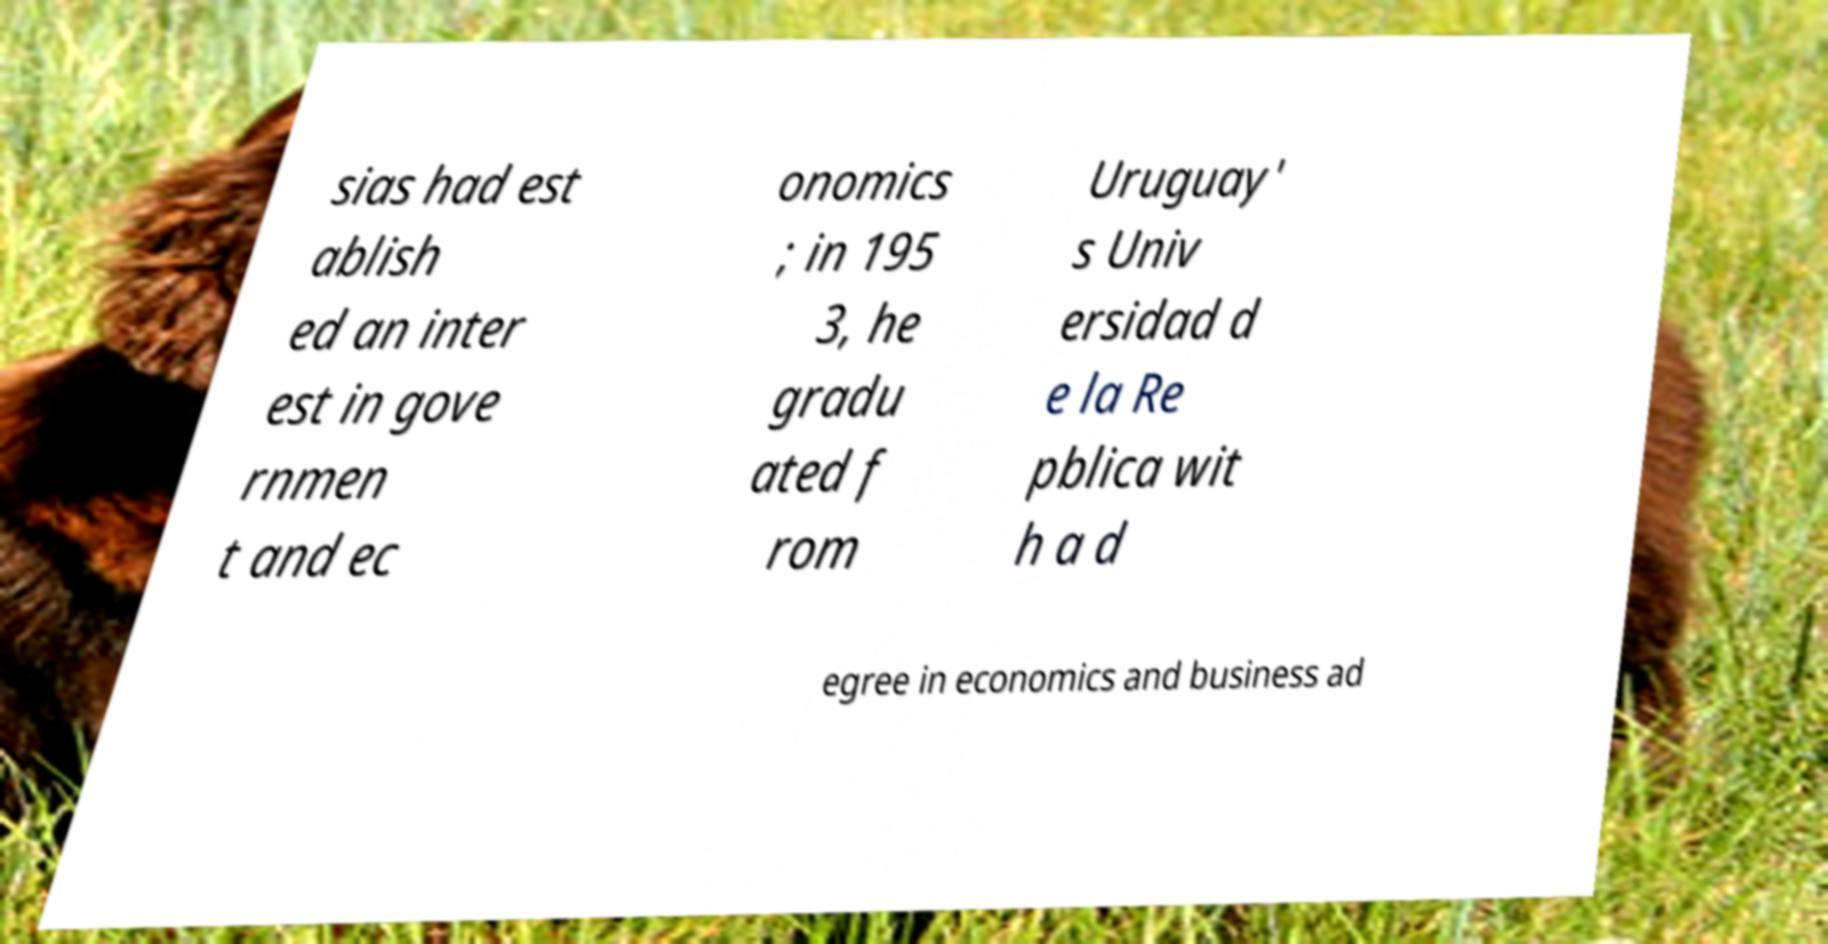Please identify and transcribe the text found in this image. sias had est ablish ed an inter est in gove rnmen t and ec onomics ; in 195 3, he gradu ated f rom Uruguay' s Univ ersidad d e la Re pblica wit h a d egree in economics and business ad 